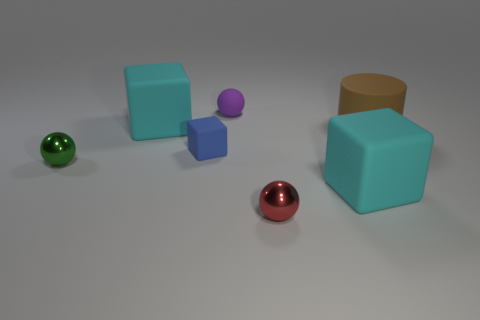Is the number of big matte blocks less than the number of tiny balls?
Your response must be concise. Yes. How many objects are either small gray objects or brown rubber cylinders?
Provide a short and direct response. 1. Do the large brown matte object and the green thing have the same shape?
Make the answer very short. No. There is a metallic thing to the left of the small purple rubber thing; does it have the same size as the cyan thing that is right of the tiny red sphere?
Your answer should be very brief. No. There is a ball that is both right of the green metallic object and behind the small red sphere; what material is it made of?
Make the answer very short. Rubber. Are there fewer big brown things that are in front of the small purple rubber thing than purple rubber blocks?
Your response must be concise. No. Is the number of cyan cubes greater than the number of matte blocks?
Offer a very short reply. No. There is a cyan cube that is behind the tiny shiny thing that is on the left side of the tiny purple rubber ball; is there a small purple matte sphere that is in front of it?
Offer a terse response. No. What number of other things are there of the same size as the brown cylinder?
Provide a short and direct response. 2. There is a small purple thing; are there any shiny things to the right of it?
Your response must be concise. Yes. 